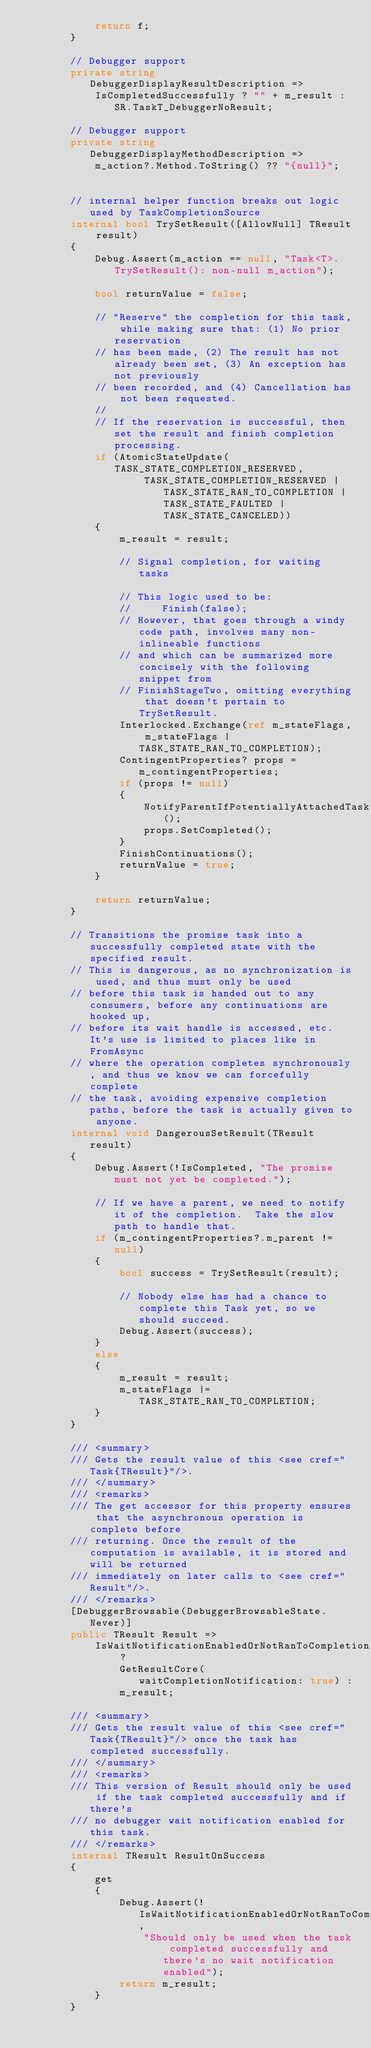<code> <loc_0><loc_0><loc_500><loc_500><_C#_>            return f;
        }

        // Debugger support
        private string DebuggerDisplayResultDescription =>
            IsCompletedSuccessfully ? "" + m_result : SR.TaskT_DebuggerNoResult;

        // Debugger support
        private string DebuggerDisplayMethodDescription =>
            m_action?.Method.ToString() ?? "{null}";


        // internal helper function breaks out logic used by TaskCompletionSource
        internal bool TrySetResult([AllowNull] TResult result)
        {
            Debug.Assert(m_action == null, "Task<T>.TrySetResult(): non-null m_action");

            bool returnValue = false;

            // "Reserve" the completion for this task, while making sure that: (1) No prior reservation
            // has been made, (2) The result has not already been set, (3) An exception has not previously
            // been recorded, and (4) Cancellation has not been requested.
            //
            // If the reservation is successful, then set the result and finish completion processing.
            if (AtomicStateUpdate(TASK_STATE_COMPLETION_RESERVED,
                    TASK_STATE_COMPLETION_RESERVED | TASK_STATE_RAN_TO_COMPLETION | TASK_STATE_FAULTED | TASK_STATE_CANCELED))
            {
                m_result = result;

                // Signal completion, for waiting tasks

                // This logic used to be:
                //     Finish(false);
                // However, that goes through a windy code path, involves many non-inlineable functions
                // and which can be summarized more concisely with the following snippet from
                // FinishStageTwo, omitting everything that doesn't pertain to TrySetResult.
                Interlocked.Exchange(ref m_stateFlags, m_stateFlags | TASK_STATE_RAN_TO_COMPLETION);
                ContingentProperties? props = m_contingentProperties;
                if (props != null)
                {
                    NotifyParentIfPotentiallyAttachedTask();
                    props.SetCompleted();
                }
                FinishContinuations();
                returnValue = true;
            }

            return returnValue;
        }

        // Transitions the promise task into a successfully completed state with the specified result.
        // This is dangerous, as no synchronization is used, and thus must only be used
        // before this task is handed out to any consumers, before any continuations are hooked up,
        // before its wait handle is accessed, etc.  It's use is limited to places like in FromAsync
        // where the operation completes synchronously, and thus we know we can forcefully complete
        // the task, avoiding expensive completion paths, before the task is actually given to anyone.
        internal void DangerousSetResult(TResult result)
        {
            Debug.Assert(!IsCompleted, "The promise must not yet be completed.");

            // If we have a parent, we need to notify it of the completion.  Take the slow path to handle that.
            if (m_contingentProperties?.m_parent != null)
            {
                bool success = TrySetResult(result);

                // Nobody else has had a chance to complete this Task yet, so we should succeed.
                Debug.Assert(success);
            }
            else
            {
                m_result = result;
                m_stateFlags |= TASK_STATE_RAN_TO_COMPLETION;
            }
        }

        /// <summary>
        /// Gets the result value of this <see cref="Task{TResult}"/>.
        /// </summary>
        /// <remarks>
        /// The get accessor for this property ensures that the asynchronous operation is complete before
        /// returning. Once the result of the computation is available, it is stored and will be returned
        /// immediately on later calls to <see cref="Result"/>.
        /// </remarks>
        [DebuggerBrowsable(DebuggerBrowsableState.Never)]
        public TResult Result =>
            IsWaitNotificationEnabledOrNotRanToCompletion ?
                GetResultCore(waitCompletionNotification: true) :
                m_result;

        /// <summary>
        /// Gets the result value of this <see cref="Task{TResult}"/> once the task has completed successfully.
        /// </summary>
        /// <remarks>
        /// This version of Result should only be used if the task completed successfully and if there's
        /// no debugger wait notification enabled for this task.
        /// </remarks>
        internal TResult ResultOnSuccess
        {
            get
            {
                Debug.Assert(!IsWaitNotificationEnabledOrNotRanToCompletion,
                    "Should only be used when the task completed successfully and there's no wait notification enabled");
                return m_result;
            }
        }
</code> 